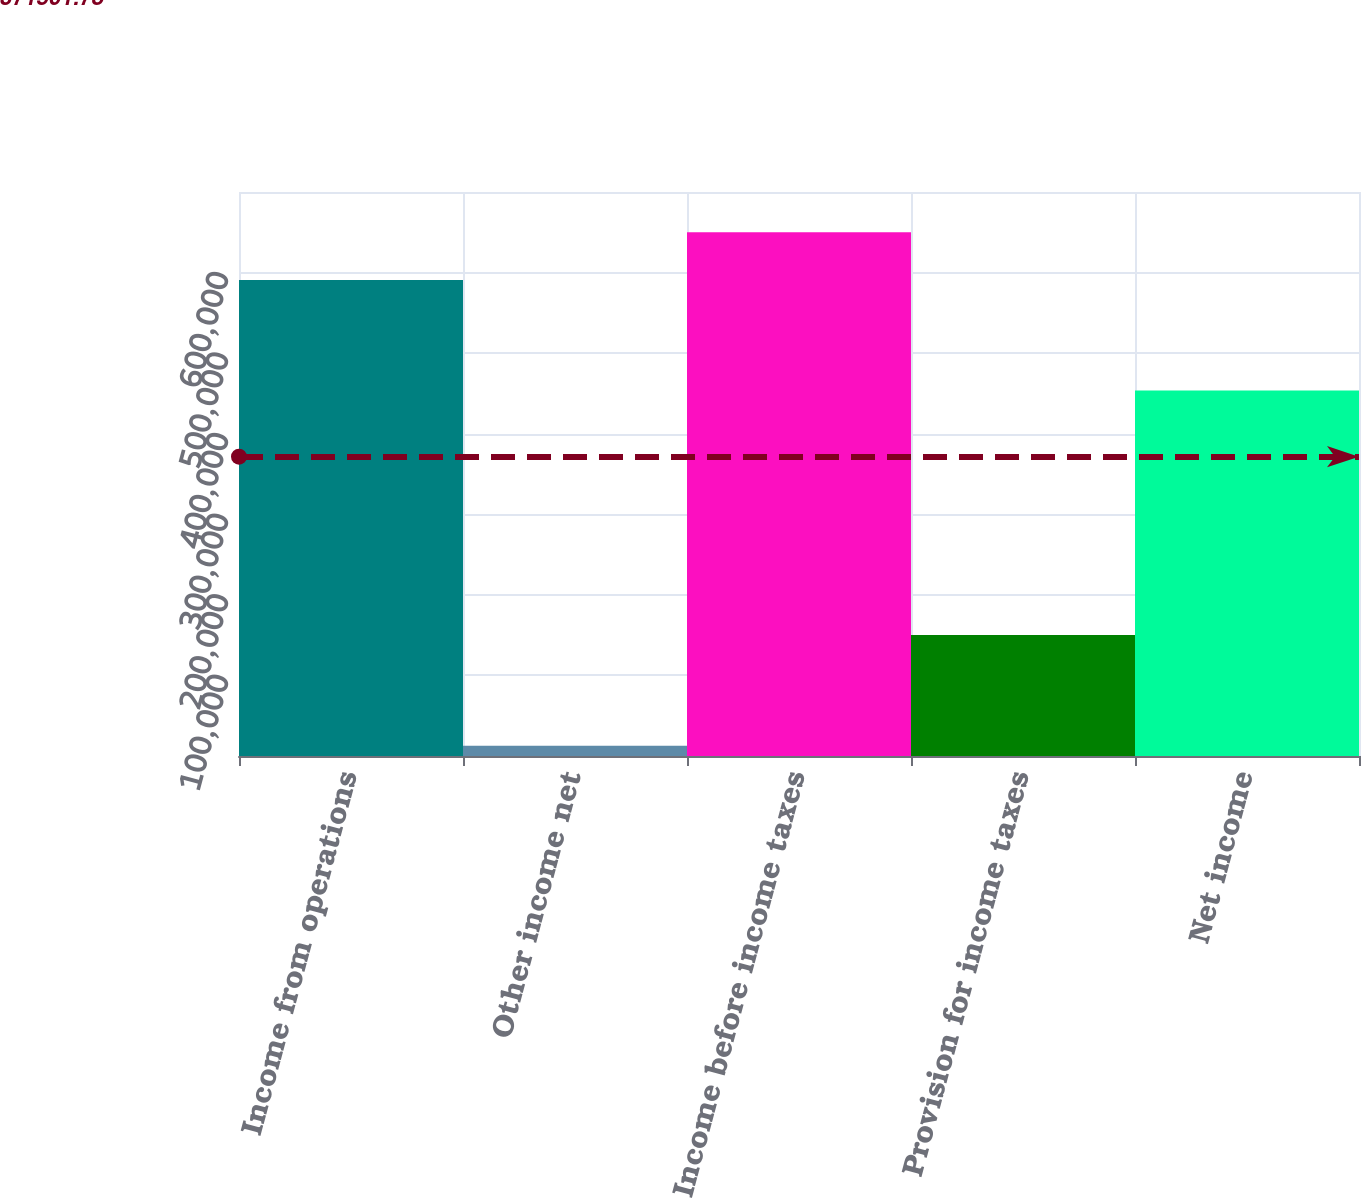Convert chart to OTSL. <chart><loc_0><loc_0><loc_500><loc_500><bar_chart><fcel>Income from operations<fcel>Other income net<fcel>Income before income taxes<fcel>Provision for income taxes<fcel>Net income<nl><fcel>590899<fcel>12861<fcel>649989<fcel>150071<fcel>453689<nl></chart> 